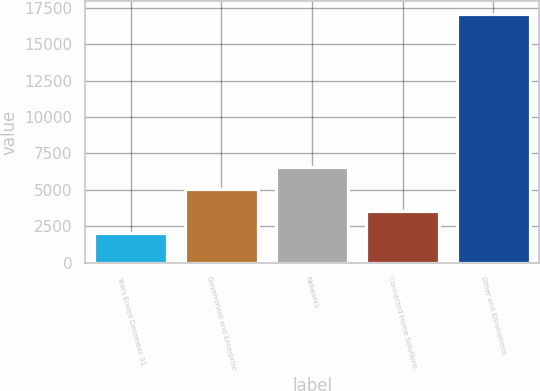<chart> <loc_0><loc_0><loc_500><loc_500><bar_chart><fcel>Years Ended December 31<fcel>Government and Enterprise<fcel>Networks<fcel>Connected Home Solutions<fcel>Other and Eliminations<nl><fcel>2004<fcel>5025.8<fcel>6536.7<fcel>3514.9<fcel>17113<nl></chart> 